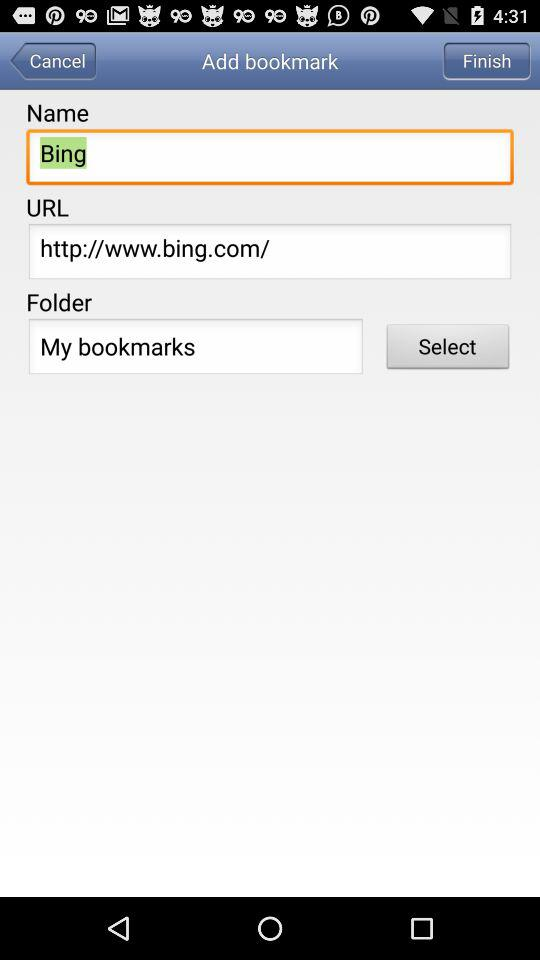How many text inputs are in the bookmark form?
Answer the question using a single word or phrase. 3 